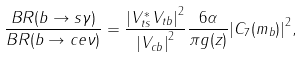<formula> <loc_0><loc_0><loc_500><loc_500>\frac { B R ( b \rightarrow s \gamma ) } { B R ( b \rightarrow c e \nu ) } = \frac { { | V _ { t s } ^ { * } V _ { t b } | } ^ { 2 } } { { | V _ { c b } | } ^ { 2 } } \frac { 6 \alpha } { \pi g ( z ) } { | C _ { 7 } ( m _ { b } ) | } ^ { 2 } ,</formula> 